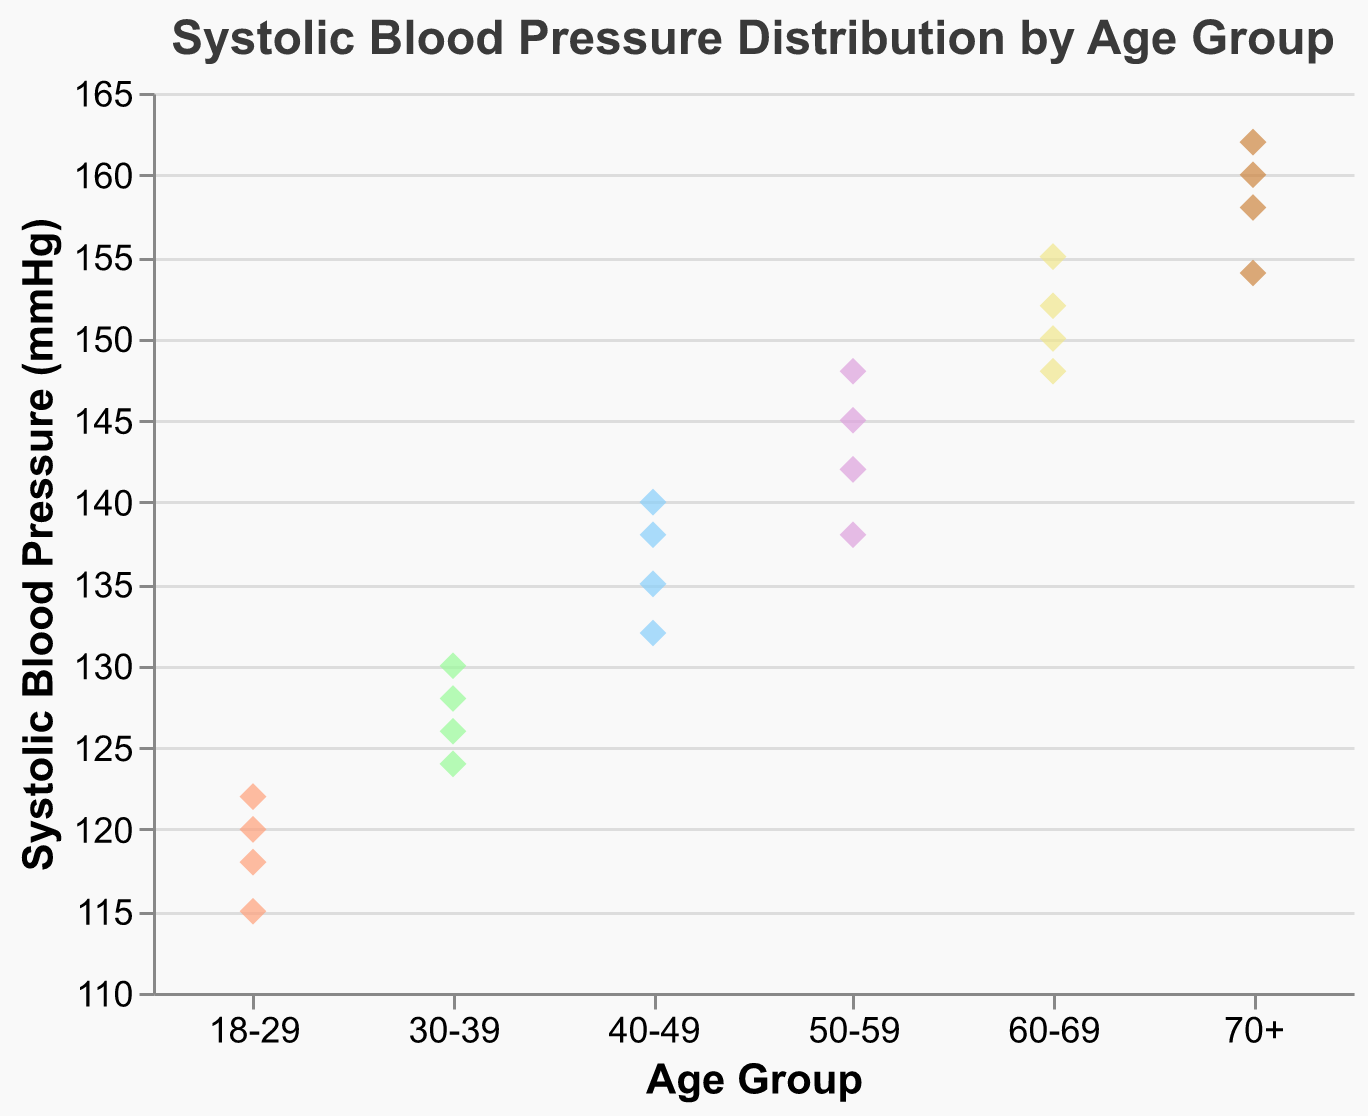What is the highest systolic blood pressure reading for the 18-29 age group? Look at the plot and find the maximum y-value for data points corresponding to the 18-29 age group. The highest reading is 122.
Answer: 122 What is the lowest systolic blood pressure reading for the 70+ age group? Look at the plot and find the minimum y-value for data points corresponding to the 70+ age group. The lowest reading is 154.
Answer: 154 Which age group has the highest variation in systolic blood pressure readings? Identify the range (difference between maximum and minimum readings) for each age group and compare. The 70+ age group has the highest range (162 - 154 = 8).
Answer: 70+ Which age group has the average systolic blood pressure closest to 140 mmHg? Calculate the average systolic blood pressure for each age group: (18-29: 118.75, 30-39: 127, 40-49: 136.25, 50-59: 143.25, 60-69: 151.25, 70+: 158.5). Compare the averages to 140 and find the closest. The 40-49 age group is closest.
Answer: 40-49 Is there any age group where all readings are above 150 mmHg? Check each age group's data points to see if all readings are above 150. Only the 70+ age group fits the criteria.
Answer: 70+ Which age group has the median systolic blood pressure reading closest to 140 mmHg? For each age group, find the median systolic blood pressure reading (18-29: 119, 30-39: 127, 40-49: 136.5, 50-59: 143.5, 60-69: 151, 70+: 159). Compare the medians to 140. The 50-59 age group is closest.
Answer: 50-59 What is the range of systolic blood pressure readings for the 60-69 age group? Identify the maximum and minimum readings for the 60-69 age group (155 and 148, respectively) and calculate the range (155 - 148).
Answer: 7 Which age group has the highest average systolic blood pressure? Calculate the average systolic blood pressure for each age group and compare. The 70+ age group has the highest average of 158.5 mmHg.
Answer: 70+ Which age group has the lowest median systolic blood pressure reading? Calculate the median systolic blood pressure for each age group (18-29: 119, 30-39: 127, 40-49: 136.5, 50-59: 143.5, 60-69: 151, 70+: 159) and find the lowest. The 18-29 age group has the lowest median of 119.
Answer: 18-29 